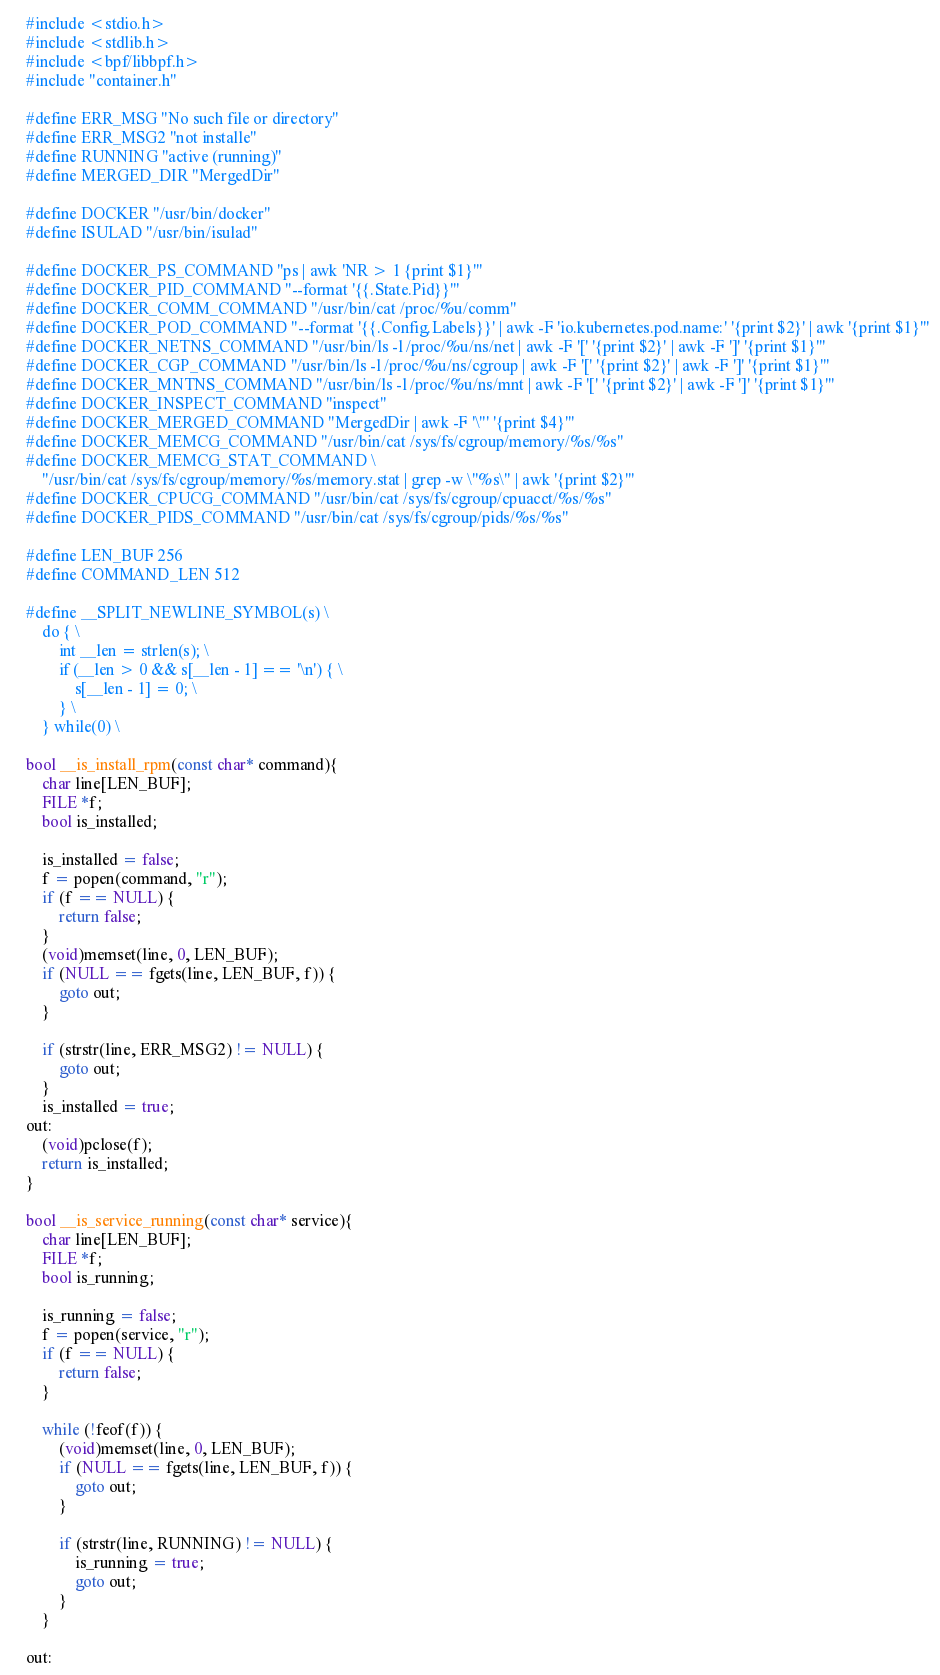<code> <loc_0><loc_0><loc_500><loc_500><_C_>#include <stdio.h>
#include <stdlib.h>
#include <bpf/libbpf.h>
#include "container.h"

#define ERR_MSG "No such file or directory"
#define ERR_MSG2 "not installe"
#define RUNNING "active (running)"
#define MERGED_DIR "MergedDir"

#define DOCKER "/usr/bin/docker"
#define ISULAD "/usr/bin/isulad"

#define DOCKER_PS_COMMAND "ps | awk 'NR > 1 {print $1}'"
#define DOCKER_PID_COMMAND "--format '{{.State.Pid}}'"
#define DOCKER_COMM_COMMAND "/usr/bin/cat /proc/%u/comm"
#define DOCKER_POD_COMMAND "--format '{{.Config.Labels}}' | awk -F 'io.kubernetes.pod.name:' '{print $2}' | awk '{print $1}'"
#define DOCKER_NETNS_COMMAND "/usr/bin/ls -l /proc/%u/ns/net | awk -F '[' '{print $2}' | awk -F ']' '{print $1}'"
#define DOCKER_CGP_COMMAND "/usr/bin/ls -l /proc/%u/ns/cgroup | awk -F '[' '{print $2}' | awk -F ']' '{print $1}'"
#define DOCKER_MNTNS_COMMAND "/usr/bin/ls -l /proc/%u/ns/mnt | awk -F '[' '{print $2}' | awk -F ']' '{print $1}'"
#define DOCKER_INSPECT_COMMAND "inspect"
#define DOCKER_MERGED_COMMAND "MergedDir | awk -F '\"' '{print $4}'"
#define DOCKER_MEMCG_COMMAND "/usr/bin/cat /sys/fs/cgroup/memory/%s/%s"
#define DOCKER_MEMCG_STAT_COMMAND \
    "/usr/bin/cat /sys/fs/cgroup/memory/%s/memory.stat | grep -w \"%s\" | awk '{print $2}'"
#define DOCKER_CPUCG_COMMAND "/usr/bin/cat /sys/fs/cgroup/cpuacct/%s/%s"
#define DOCKER_PIDS_COMMAND "/usr/bin/cat /sys/fs/cgroup/pids/%s/%s"

#define LEN_BUF 256
#define COMMAND_LEN 512

#define __SPLIT_NEWLINE_SYMBOL(s) \
    do { \
        int __len = strlen(s); \
        if (__len > 0 && s[__len - 1] == '\n') { \
            s[__len - 1] = 0; \
        } \
    } while(0) \

bool __is_install_rpm(const char* command){
    char line[LEN_BUF];
    FILE *f;
    bool is_installed;

    is_installed = false;
    f = popen(command, "r");
    if (f == NULL) {
        return false;
    }
    (void)memset(line, 0, LEN_BUF);
    if (NULL == fgets(line, LEN_BUF, f)) {
        goto out;
    }

    if (strstr(line, ERR_MSG2) != NULL) {
        goto out;            
    }
    is_installed = true;
out:
    (void)pclose(f);
    return is_installed;
}

bool __is_service_running(const char* service){
    char line[LEN_BUF];
    FILE *f;
    bool is_running;

    is_running = false;
    f = popen(service, "r");
    if (f == NULL) {
        return false;
    }
    
    while (!feof(f)) {
        (void)memset(line, 0, LEN_BUF);
        if (NULL == fgets(line, LEN_BUF, f)) {
            goto out;
        }

        if (strstr(line, RUNNING) != NULL) {
            is_running = true;
            goto out;            
        }
    }
    
out:</code> 